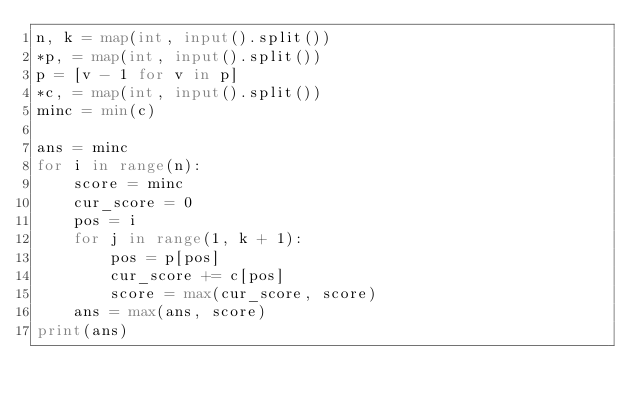<code> <loc_0><loc_0><loc_500><loc_500><_Python_>n, k = map(int, input().split())
*p, = map(int, input().split())
p = [v - 1 for v in p]
*c, = map(int, input().split())
minc = min(c)

ans = minc
for i in range(n):
    score = minc
    cur_score = 0
    pos = i
    for j in range(1, k + 1):
        pos = p[pos]
        cur_score += c[pos]
        score = max(cur_score, score)
    ans = max(ans, score)
print(ans)


</code> 